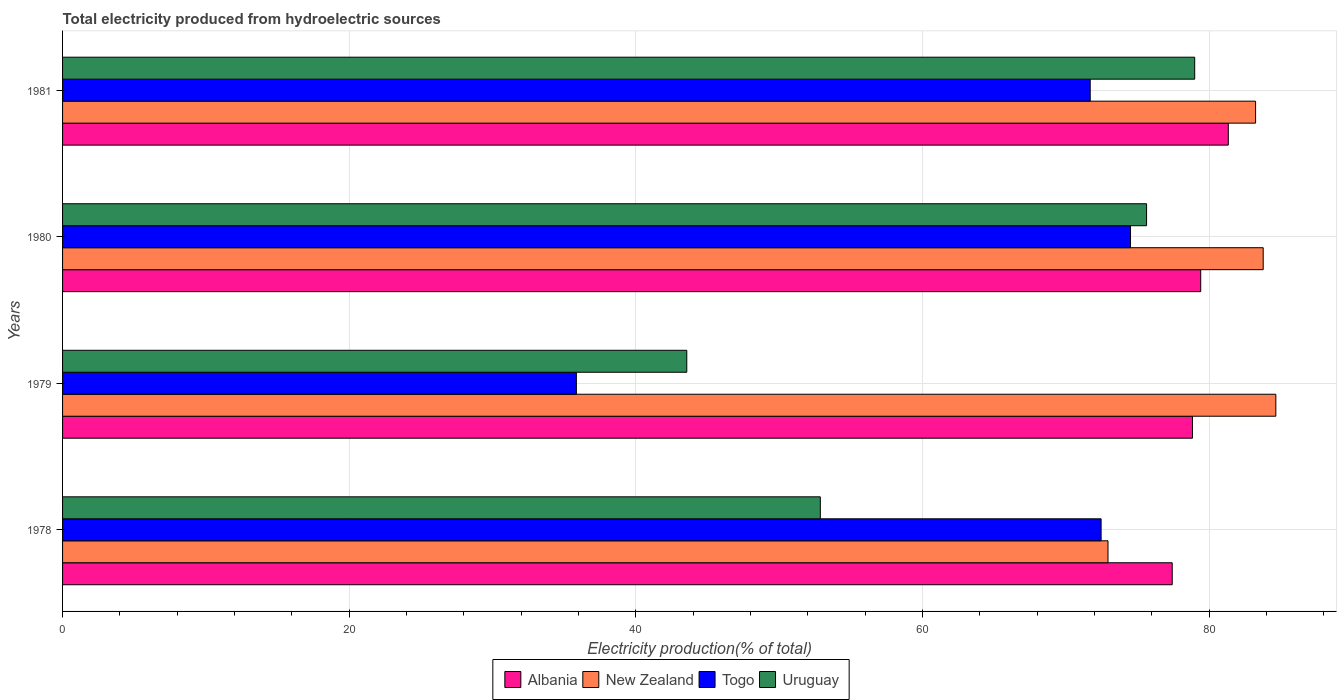How many different coloured bars are there?
Provide a short and direct response. 4. How many groups of bars are there?
Keep it short and to the point. 4. Are the number of bars on each tick of the Y-axis equal?
Keep it short and to the point. Yes. How many bars are there on the 3rd tick from the top?
Offer a terse response. 4. What is the label of the 3rd group of bars from the top?
Your response must be concise. 1979. In how many cases, is the number of bars for a given year not equal to the number of legend labels?
Your answer should be very brief. 0. What is the total electricity produced in New Zealand in 1980?
Your answer should be compact. 83.77. Across all years, what is the maximum total electricity produced in Albania?
Your answer should be very brief. 81.33. Across all years, what is the minimum total electricity produced in New Zealand?
Your answer should be very brief. 72.94. In which year was the total electricity produced in Albania minimum?
Offer a very short reply. 1978. What is the total total electricity produced in Albania in the graph?
Your response must be concise. 316.99. What is the difference between the total electricity produced in Togo in 1978 and that in 1980?
Provide a succinct answer. -2.05. What is the difference between the total electricity produced in Togo in 1979 and the total electricity produced in Albania in 1980?
Provide a short and direct response. -43.56. What is the average total electricity produced in Albania per year?
Ensure brevity in your answer.  79.25. In the year 1979, what is the difference between the total electricity produced in Uruguay and total electricity produced in New Zealand?
Offer a very short reply. -41.1. In how many years, is the total electricity produced in Albania greater than 24 %?
Make the answer very short. 4. What is the ratio of the total electricity produced in Uruguay in 1980 to that in 1981?
Offer a very short reply. 0.96. Is the total electricity produced in Albania in 1979 less than that in 1980?
Make the answer very short. Yes. What is the difference between the highest and the second highest total electricity produced in Albania?
Your answer should be compact. 1.93. What is the difference between the highest and the lowest total electricity produced in Togo?
Ensure brevity in your answer.  38.66. What does the 3rd bar from the top in 1979 represents?
Offer a very short reply. New Zealand. What does the 1st bar from the bottom in 1978 represents?
Your answer should be compact. Albania. Are all the bars in the graph horizontal?
Your response must be concise. Yes. How many years are there in the graph?
Provide a succinct answer. 4. What is the difference between two consecutive major ticks on the X-axis?
Ensure brevity in your answer.  20. Are the values on the major ticks of X-axis written in scientific E-notation?
Offer a very short reply. No. Where does the legend appear in the graph?
Provide a short and direct response. Bottom center. How many legend labels are there?
Provide a succinct answer. 4. What is the title of the graph?
Your answer should be very brief. Total electricity produced from hydroelectric sources. What is the Electricity production(% of total) in Albania in 1978?
Make the answer very short. 77.42. What is the Electricity production(% of total) of New Zealand in 1978?
Offer a very short reply. 72.94. What is the Electricity production(% of total) of Togo in 1978?
Make the answer very short. 72.46. What is the Electricity production(% of total) in Uruguay in 1978?
Provide a succinct answer. 52.87. What is the Electricity production(% of total) in Albania in 1979?
Provide a short and direct response. 78.83. What is the Electricity production(% of total) in New Zealand in 1979?
Your answer should be compact. 84.65. What is the Electricity production(% of total) of Togo in 1979?
Make the answer very short. 35.85. What is the Electricity production(% of total) in Uruguay in 1979?
Offer a very short reply. 43.55. What is the Electricity production(% of total) of Albania in 1980?
Keep it short and to the point. 79.41. What is the Electricity production(% of total) of New Zealand in 1980?
Your answer should be compact. 83.77. What is the Electricity production(% of total) in Togo in 1980?
Offer a terse response. 74.51. What is the Electricity production(% of total) of Uruguay in 1980?
Keep it short and to the point. 75.63. What is the Electricity production(% of total) in Albania in 1981?
Ensure brevity in your answer.  81.33. What is the Electricity production(% of total) in New Zealand in 1981?
Your response must be concise. 83.24. What is the Electricity production(% of total) in Togo in 1981?
Make the answer very short. 71.7. What is the Electricity production(% of total) of Uruguay in 1981?
Ensure brevity in your answer.  78.99. Across all years, what is the maximum Electricity production(% of total) of Albania?
Offer a very short reply. 81.33. Across all years, what is the maximum Electricity production(% of total) of New Zealand?
Your answer should be compact. 84.65. Across all years, what is the maximum Electricity production(% of total) in Togo?
Provide a succinct answer. 74.51. Across all years, what is the maximum Electricity production(% of total) of Uruguay?
Make the answer very short. 78.99. Across all years, what is the minimum Electricity production(% of total) in Albania?
Provide a succinct answer. 77.42. Across all years, what is the minimum Electricity production(% of total) in New Zealand?
Give a very brief answer. 72.94. Across all years, what is the minimum Electricity production(% of total) of Togo?
Your answer should be compact. 35.85. Across all years, what is the minimum Electricity production(% of total) in Uruguay?
Keep it short and to the point. 43.55. What is the total Electricity production(% of total) in Albania in the graph?
Make the answer very short. 316.99. What is the total Electricity production(% of total) of New Zealand in the graph?
Make the answer very short. 324.59. What is the total Electricity production(% of total) of Togo in the graph?
Keep it short and to the point. 254.51. What is the total Electricity production(% of total) in Uruguay in the graph?
Your answer should be compact. 251.04. What is the difference between the Electricity production(% of total) of Albania in 1978 and that in 1979?
Your response must be concise. -1.41. What is the difference between the Electricity production(% of total) in New Zealand in 1978 and that in 1979?
Make the answer very short. -11.71. What is the difference between the Electricity production(% of total) of Togo in 1978 and that in 1979?
Keep it short and to the point. 36.61. What is the difference between the Electricity production(% of total) of Uruguay in 1978 and that in 1979?
Provide a succinct answer. 9.32. What is the difference between the Electricity production(% of total) of Albania in 1978 and that in 1980?
Offer a terse response. -1.99. What is the difference between the Electricity production(% of total) in New Zealand in 1978 and that in 1980?
Your answer should be compact. -10.83. What is the difference between the Electricity production(% of total) of Togo in 1978 and that in 1980?
Keep it short and to the point. -2.05. What is the difference between the Electricity production(% of total) in Uruguay in 1978 and that in 1980?
Keep it short and to the point. -22.76. What is the difference between the Electricity production(% of total) in Albania in 1978 and that in 1981?
Make the answer very short. -3.91. What is the difference between the Electricity production(% of total) of New Zealand in 1978 and that in 1981?
Make the answer very short. -10.3. What is the difference between the Electricity production(% of total) in Togo in 1978 and that in 1981?
Offer a terse response. 0.76. What is the difference between the Electricity production(% of total) of Uruguay in 1978 and that in 1981?
Make the answer very short. -26.12. What is the difference between the Electricity production(% of total) in Albania in 1979 and that in 1980?
Provide a short and direct response. -0.58. What is the difference between the Electricity production(% of total) of New Zealand in 1979 and that in 1980?
Make the answer very short. 0.88. What is the difference between the Electricity production(% of total) in Togo in 1979 and that in 1980?
Provide a short and direct response. -38.66. What is the difference between the Electricity production(% of total) in Uruguay in 1979 and that in 1980?
Give a very brief answer. -32.08. What is the difference between the Electricity production(% of total) of Albania in 1979 and that in 1981?
Your answer should be compact. -2.5. What is the difference between the Electricity production(% of total) of New Zealand in 1979 and that in 1981?
Your answer should be very brief. 1.41. What is the difference between the Electricity production(% of total) in Togo in 1979 and that in 1981?
Ensure brevity in your answer.  -35.85. What is the difference between the Electricity production(% of total) of Uruguay in 1979 and that in 1981?
Provide a succinct answer. -35.44. What is the difference between the Electricity production(% of total) in Albania in 1980 and that in 1981?
Ensure brevity in your answer.  -1.93. What is the difference between the Electricity production(% of total) of New Zealand in 1980 and that in 1981?
Offer a terse response. 0.53. What is the difference between the Electricity production(% of total) of Togo in 1980 and that in 1981?
Give a very brief answer. 2.81. What is the difference between the Electricity production(% of total) of Uruguay in 1980 and that in 1981?
Your response must be concise. -3.36. What is the difference between the Electricity production(% of total) of Albania in 1978 and the Electricity production(% of total) of New Zealand in 1979?
Your response must be concise. -7.23. What is the difference between the Electricity production(% of total) of Albania in 1978 and the Electricity production(% of total) of Togo in 1979?
Provide a short and direct response. 41.57. What is the difference between the Electricity production(% of total) of Albania in 1978 and the Electricity production(% of total) of Uruguay in 1979?
Provide a short and direct response. 33.87. What is the difference between the Electricity production(% of total) in New Zealand in 1978 and the Electricity production(% of total) in Togo in 1979?
Give a very brief answer. 37.09. What is the difference between the Electricity production(% of total) of New Zealand in 1978 and the Electricity production(% of total) of Uruguay in 1979?
Keep it short and to the point. 29.39. What is the difference between the Electricity production(% of total) of Togo in 1978 and the Electricity production(% of total) of Uruguay in 1979?
Provide a short and direct response. 28.91. What is the difference between the Electricity production(% of total) of Albania in 1978 and the Electricity production(% of total) of New Zealand in 1980?
Provide a succinct answer. -6.35. What is the difference between the Electricity production(% of total) of Albania in 1978 and the Electricity production(% of total) of Togo in 1980?
Ensure brevity in your answer.  2.91. What is the difference between the Electricity production(% of total) of Albania in 1978 and the Electricity production(% of total) of Uruguay in 1980?
Your response must be concise. 1.79. What is the difference between the Electricity production(% of total) in New Zealand in 1978 and the Electricity production(% of total) in Togo in 1980?
Your response must be concise. -1.57. What is the difference between the Electricity production(% of total) in New Zealand in 1978 and the Electricity production(% of total) in Uruguay in 1980?
Offer a very short reply. -2.69. What is the difference between the Electricity production(% of total) in Togo in 1978 and the Electricity production(% of total) in Uruguay in 1980?
Your answer should be very brief. -3.17. What is the difference between the Electricity production(% of total) of Albania in 1978 and the Electricity production(% of total) of New Zealand in 1981?
Keep it short and to the point. -5.82. What is the difference between the Electricity production(% of total) in Albania in 1978 and the Electricity production(% of total) in Togo in 1981?
Give a very brief answer. 5.72. What is the difference between the Electricity production(% of total) of Albania in 1978 and the Electricity production(% of total) of Uruguay in 1981?
Keep it short and to the point. -1.57. What is the difference between the Electricity production(% of total) of New Zealand in 1978 and the Electricity production(% of total) of Togo in 1981?
Offer a terse response. 1.24. What is the difference between the Electricity production(% of total) in New Zealand in 1978 and the Electricity production(% of total) in Uruguay in 1981?
Make the answer very short. -6.05. What is the difference between the Electricity production(% of total) in Togo in 1978 and the Electricity production(% of total) in Uruguay in 1981?
Ensure brevity in your answer.  -6.53. What is the difference between the Electricity production(% of total) in Albania in 1979 and the Electricity production(% of total) in New Zealand in 1980?
Give a very brief answer. -4.93. What is the difference between the Electricity production(% of total) of Albania in 1979 and the Electricity production(% of total) of Togo in 1980?
Your response must be concise. 4.32. What is the difference between the Electricity production(% of total) in Albania in 1979 and the Electricity production(% of total) in Uruguay in 1980?
Your answer should be very brief. 3.2. What is the difference between the Electricity production(% of total) in New Zealand in 1979 and the Electricity production(% of total) in Togo in 1980?
Your response must be concise. 10.14. What is the difference between the Electricity production(% of total) of New Zealand in 1979 and the Electricity production(% of total) of Uruguay in 1980?
Keep it short and to the point. 9.02. What is the difference between the Electricity production(% of total) in Togo in 1979 and the Electricity production(% of total) in Uruguay in 1980?
Provide a short and direct response. -39.78. What is the difference between the Electricity production(% of total) of Albania in 1979 and the Electricity production(% of total) of New Zealand in 1981?
Keep it short and to the point. -4.4. What is the difference between the Electricity production(% of total) in Albania in 1979 and the Electricity production(% of total) in Togo in 1981?
Provide a short and direct response. 7.13. What is the difference between the Electricity production(% of total) of Albania in 1979 and the Electricity production(% of total) of Uruguay in 1981?
Make the answer very short. -0.16. What is the difference between the Electricity production(% of total) in New Zealand in 1979 and the Electricity production(% of total) in Togo in 1981?
Provide a succinct answer. 12.95. What is the difference between the Electricity production(% of total) in New Zealand in 1979 and the Electricity production(% of total) in Uruguay in 1981?
Provide a succinct answer. 5.66. What is the difference between the Electricity production(% of total) in Togo in 1979 and the Electricity production(% of total) in Uruguay in 1981?
Your answer should be compact. -43.14. What is the difference between the Electricity production(% of total) in Albania in 1980 and the Electricity production(% of total) in New Zealand in 1981?
Ensure brevity in your answer.  -3.83. What is the difference between the Electricity production(% of total) of Albania in 1980 and the Electricity production(% of total) of Togo in 1981?
Offer a very short reply. 7.71. What is the difference between the Electricity production(% of total) of Albania in 1980 and the Electricity production(% of total) of Uruguay in 1981?
Offer a very short reply. 0.42. What is the difference between the Electricity production(% of total) in New Zealand in 1980 and the Electricity production(% of total) in Togo in 1981?
Make the answer very short. 12.07. What is the difference between the Electricity production(% of total) in New Zealand in 1980 and the Electricity production(% of total) in Uruguay in 1981?
Give a very brief answer. 4.78. What is the difference between the Electricity production(% of total) in Togo in 1980 and the Electricity production(% of total) in Uruguay in 1981?
Your answer should be very brief. -4.48. What is the average Electricity production(% of total) in Albania per year?
Provide a succinct answer. 79.25. What is the average Electricity production(% of total) of New Zealand per year?
Offer a terse response. 81.15. What is the average Electricity production(% of total) in Togo per year?
Offer a terse response. 63.63. What is the average Electricity production(% of total) of Uruguay per year?
Your answer should be very brief. 62.76. In the year 1978, what is the difference between the Electricity production(% of total) of Albania and Electricity production(% of total) of New Zealand?
Provide a short and direct response. 4.48. In the year 1978, what is the difference between the Electricity production(% of total) in Albania and Electricity production(% of total) in Togo?
Give a very brief answer. 4.96. In the year 1978, what is the difference between the Electricity production(% of total) in Albania and Electricity production(% of total) in Uruguay?
Provide a short and direct response. 24.55. In the year 1978, what is the difference between the Electricity production(% of total) in New Zealand and Electricity production(% of total) in Togo?
Offer a terse response. 0.48. In the year 1978, what is the difference between the Electricity production(% of total) in New Zealand and Electricity production(% of total) in Uruguay?
Provide a short and direct response. 20.07. In the year 1978, what is the difference between the Electricity production(% of total) in Togo and Electricity production(% of total) in Uruguay?
Your response must be concise. 19.59. In the year 1979, what is the difference between the Electricity production(% of total) of Albania and Electricity production(% of total) of New Zealand?
Offer a terse response. -5.82. In the year 1979, what is the difference between the Electricity production(% of total) in Albania and Electricity production(% of total) in Togo?
Provide a succinct answer. 42.98. In the year 1979, what is the difference between the Electricity production(% of total) in Albania and Electricity production(% of total) in Uruguay?
Provide a succinct answer. 35.28. In the year 1979, what is the difference between the Electricity production(% of total) in New Zealand and Electricity production(% of total) in Togo?
Make the answer very short. 48.8. In the year 1979, what is the difference between the Electricity production(% of total) of New Zealand and Electricity production(% of total) of Uruguay?
Your response must be concise. 41.1. In the year 1979, what is the difference between the Electricity production(% of total) in Togo and Electricity production(% of total) in Uruguay?
Provide a succinct answer. -7.7. In the year 1980, what is the difference between the Electricity production(% of total) in Albania and Electricity production(% of total) in New Zealand?
Give a very brief answer. -4.36. In the year 1980, what is the difference between the Electricity production(% of total) of Albania and Electricity production(% of total) of Togo?
Your response must be concise. 4.9. In the year 1980, what is the difference between the Electricity production(% of total) of Albania and Electricity production(% of total) of Uruguay?
Make the answer very short. 3.78. In the year 1980, what is the difference between the Electricity production(% of total) of New Zealand and Electricity production(% of total) of Togo?
Your response must be concise. 9.26. In the year 1980, what is the difference between the Electricity production(% of total) in New Zealand and Electricity production(% of total) in Uruguay?
Ensure brevity in your answer.  8.14. In the year 1980, what is the difference between the Electricity production(% of total) in Togo and Electricity production(% of total) in Uruguay?
Offer a terse response. -1.12. In the year 1981, what is the difference between the Electricity production(% of total) in Albania and Electricity production(% of total) in New Zealand?
Provide a succinct answer. -1.9. In the year 1981, what is the difference between the Electricity production(% of total) in Albania and Electricity production(% of total) in Togo?
Ensure brevity in your answer.  9.64. In the year 1981, what is the difference between the Electricity production(% of total) in Albania and Electricity production(% of total) in Uruguay?
Your answer should be compact. 2.35. In the year 1981, what is the difference between the Electricity production(% of total) in New Zealand and Electricity production(% of total) in Togo?
Keep it short and to the point. 11.54. In the year 1981, what is the difference between the Electricity production(% of total) of New Zealand and Electricity production(% of total) of Uruguay?
Provide a short and direct response. 4.25. In the year 1981, what is the difference between the Electricity production(% of total) in Togo and Electricity production(% of total) in Uruguay?
Your answer should be compact. -7.29. What is the ratio of the Electricity production(% of total) in Albania in 1978 to that in 1979?
Your answer should be very brief. 0.98. What is the ratio of the Electricity production(% of total) of New Zealand in 1978 to that in 1979?
Your response must be concise. 0.86. What is the ratio of the Electricity production(% of total) in Togo in 1978 to that in 1979?
Provide a short and direct response. 2.02. What is the ratio of the Electricity production(% of total) of Uruguay in 1978 to that in 1979?
Offer a terse response. 1.21. What is the ratio of the Electricity production(% of total) of New Zealand in 1978 to that in 1980?
Offer a terse response. 0.87. What is the ratio of the Electricity production(% of total) of Togo in 1978 to that in 1980?
Offer a terse response. 0.97. What is the ratio of the Electricity production(% of total) of Uruguay in 1978 to that in 1980?
Your answer should be very brief. 0.7. What is the ratio of the Electricity production(% of total) of Albania in 1978 to that in 1981?
Your response must be concise. 0.95. What is the ratio of the Electricity production(% of total) in New Zealand in 1978 to that in 1981?
Keep it short and to the point. 0.88. What is the ratio of the Electricity production(% of total) of Togo in 1978 to that in 1981?
Keep it short and to the point. 1.01. What is the ratio of the Electricity production(% of total) of Uruguay in 1978 to that in 1981?
Your answer should be compact. 0.67. What is the ratio of the Electricity production(% of total) of Albania in 1979 to that in 1980?
Offer a very short reply. 0.99. What is the ratio of the Electricity production(% of total) in New Zealand in 1979 to that in 1980?
Your response must be concise. 1.01. What is the ratio of the Electricity production(% of total) of Togo in 1979 to that in 1980?
Provide a succinct answer. 0.48. What is the ratio of the Electricity production(% of total) in Uruguay in 1979 to that in 1980?
Offer a terse response. 0.58. What is the ratio of the Electricity production(% of total) of Albania in 1979 to that in 1981?
Offer a very short reply. 0.97. What is the ratio of the Electricity production(% of total) of Uruguay in 1979 to that in 1981?
Provide a short and direct response. 0.55. What is the ratio of the Electricity production(% of total) in Albania in 1980 to that in 1981?
Provide a short and direct response. 0.98. What is the ratio of the Electricity production(% of total) in New Zealand in 1980 to that in 1981?
Your response must be concise. 1.01. What is the ratio of the Electricity production(% of total) in Togo in 1980 to that in 1981?
Ensure brevity in your answer.  1.04. What is the ratio of the Electricity production(% of total) in Uruguay in 1980 to that in 1981?
Provide a short and direct response. 0.96. What is the difference between the highest and the second highest Electricity production(% of total) of Albania?
Offer a very short reply. 1.93. What is the difference between the highest and the second highest Electricity production(% of total) in New Zealand?
Provide a succinct answer. 0.88. What is the difference between the highest and the second highest Electricity production(% of total) in Togo?
Provide a succinct answer. 2.05. What is the difference between the highest and the second highest Electricity production(% of total) of Uruguay?
Your answer should be compact. 3.36. What is the difference between the highest and the lowest Electricity production(% of total) in Albania?
Your answer should be compact. 3.91. What is the difference between the highest and the lowest Electricity production(% of total) in New Zealand?
Ensure brevity in your answer.  11.71. What is the difference between the highest and the lowest Electricity production(% of total) in Togo?
Keep it short and to the point. 38.66. What is the difference between the highest and the lowest Electricity production(% of total) in Uruguay?
Keep it short and to the point. 35.44. 